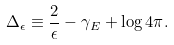<formula> <loc_0><loc_0><loc_500><loc_500>\Delta _ { \epsilon } \equiv \frac { 2 } { \epsilon } - \gamma _ { E } + \log 4 \pi .</formula> 